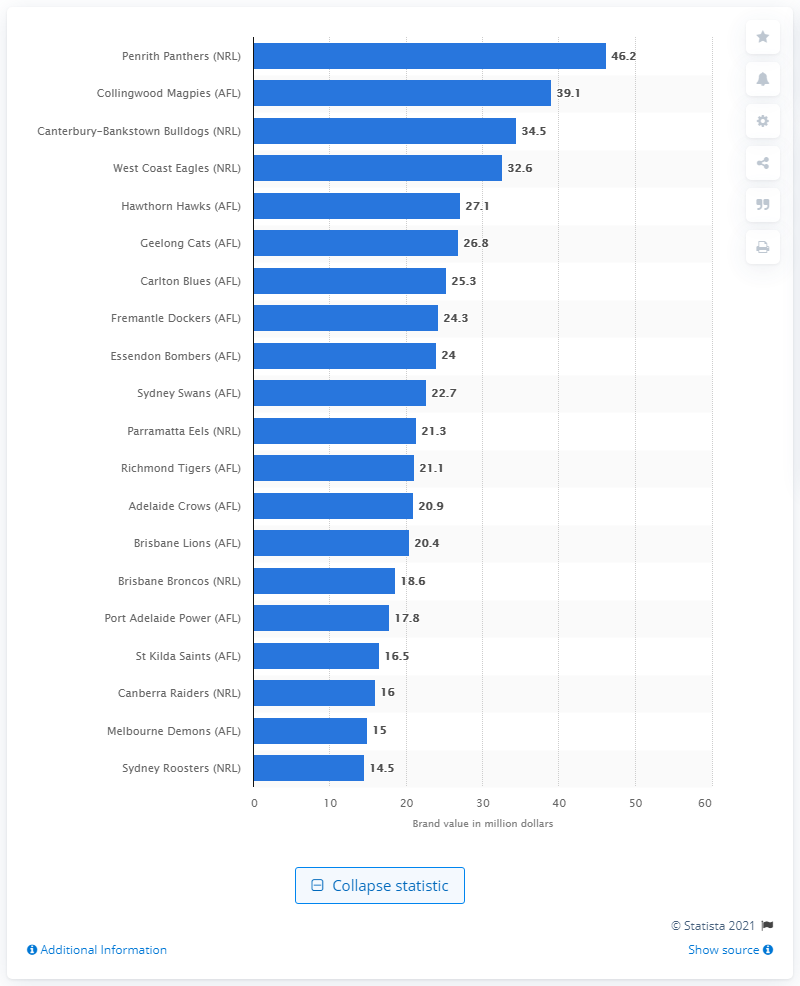Draw attention to some important aspects in this diagram. The brand value of the Penrith Panthers in 2013 was 46.2. 